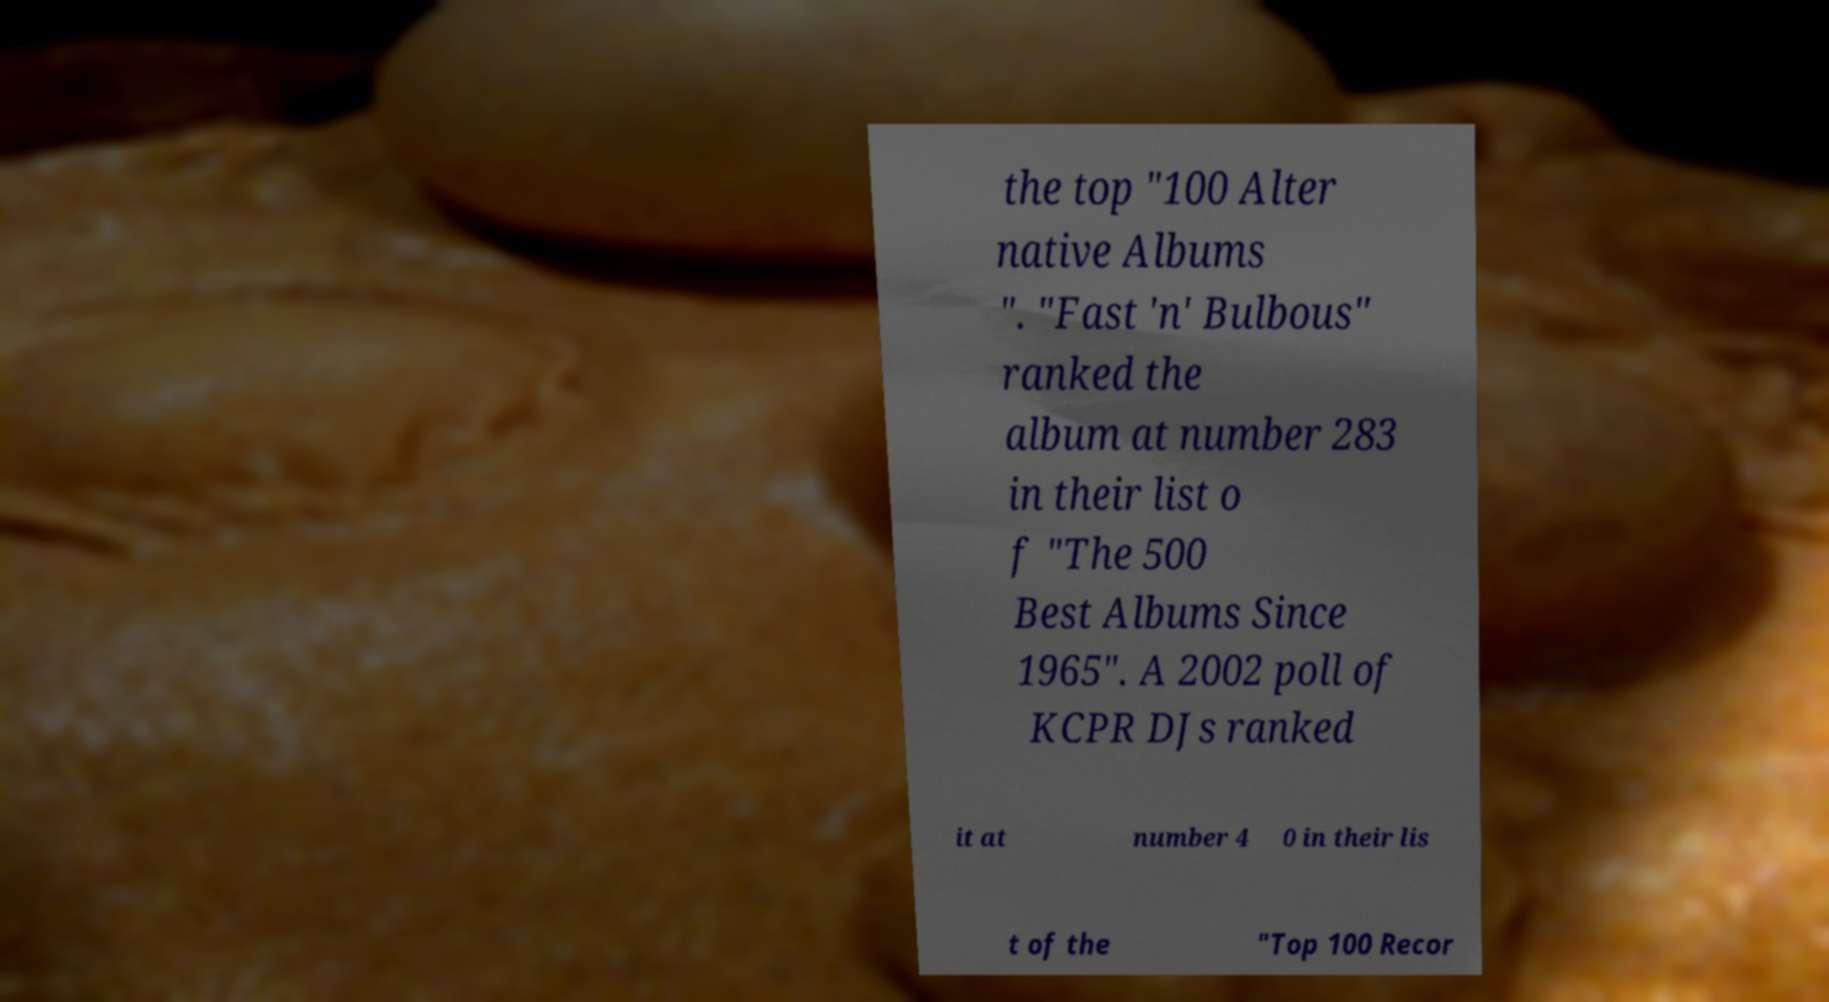Please read and relay the text visible in this image. What does it say? the top "100 Alter native Albums ". "Fast 'n' Bulbous" ranked the album at number 283 in their list o f "The 500 Best Albums Since 1965". A 2002 poll of KCPR DJs ranked it at number 4 0 in their lis t of the "Top 100 Recor 